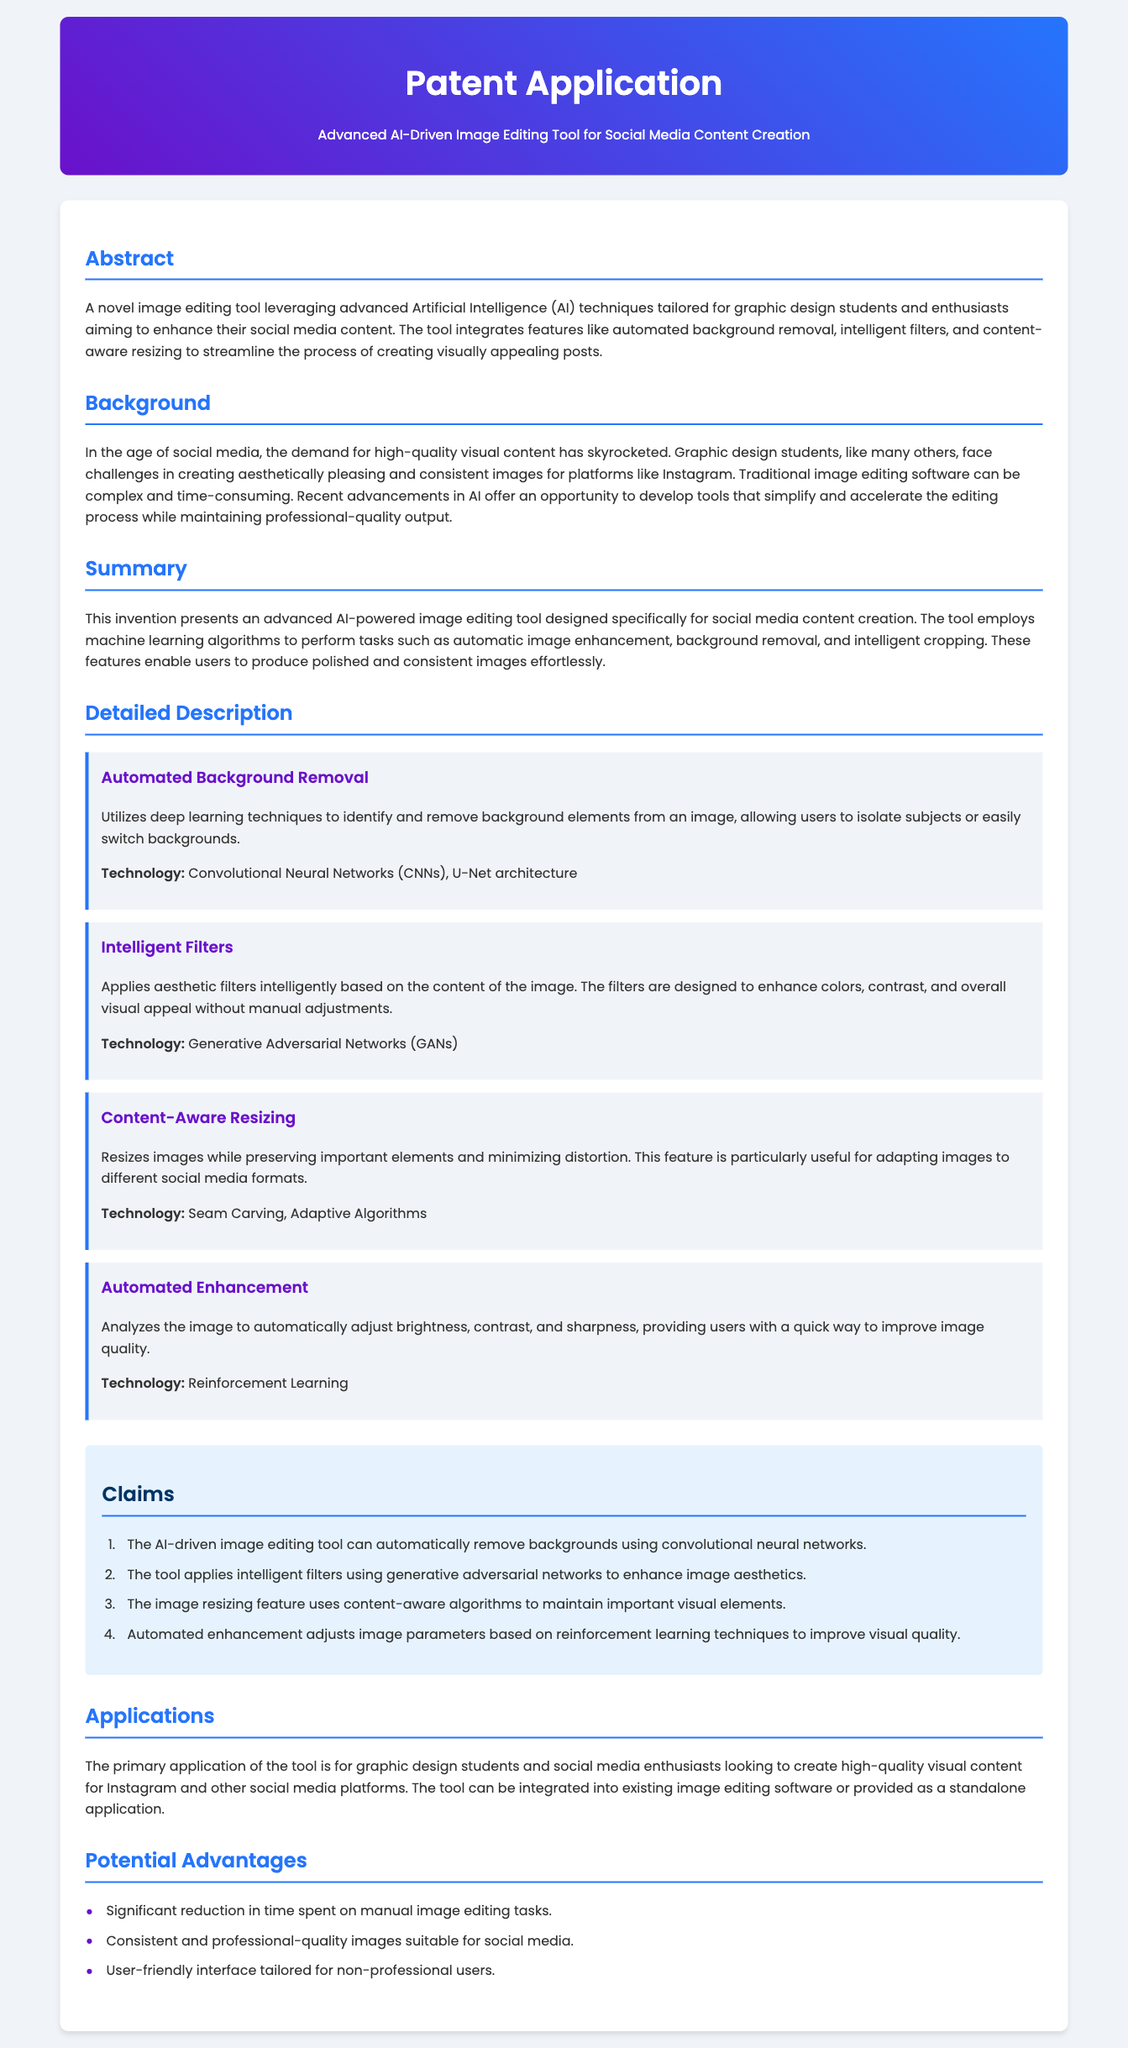what is the title of the patent application? The title is specified in the header of the document.
Answer: Advanced AI-Driven Image Editing Tool for Social Media Content Creation what is one of the main features of the image editing tool? The document lists several features under the detailed description.
Answer: Automated Background Removal what technology is used for intelligent filters? The document specifies the technology used for implementing intelligent filters.
Answer: Generative Adversarial Networks who is the primary target audience for this tool? The document identifies the target audience in the applications section.
Answer: Graphic design students and social media enthusiasts how many claims are made in the patent application? The claims are enumerated in the claims section of the document.
Answer: Four what does the automated enhancement feature do? The document describes the function of the automated enhancement feature.
Answer: Adjusts brightness, contrast, and sharpness what is the purpose of the tool? The purpose is defined in the abstract and applications sections.
Answer: To enhance social media content what is one potential advantage of the tool? Advantages are listed in the potential advantages section of the document.
Answer: Significant reduction in time spent on manual image editing tasks 